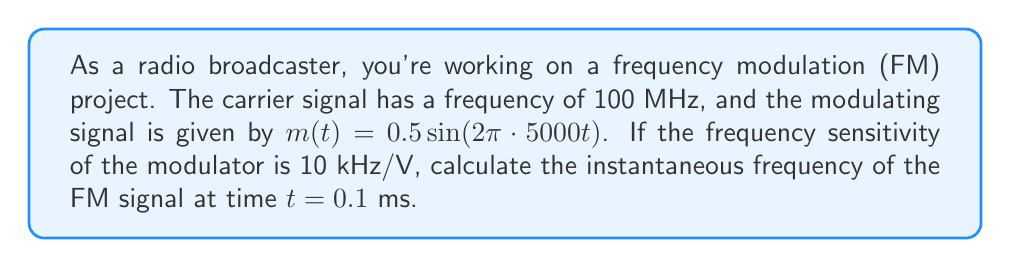Can you solve this math problem? To solve this problem, we'll follow these steps:

1) The general formula for the instantaneous frequency of an FM signal is:

   $$f_i(t) = f_c + k_f \cdot m(t)$$

   where $f_c$ is the carrier frequency, $k_f$ is the frequency sensitivity, and $m(t)$ is the modulating signal.

2) We're given:
   - $f_c = 100$ MHz $= 100 \cdot 10^6$ Hz
   - $k_f = 10$ kHz/V $= 10 \cdot 10^3$ Hz/V
   - $m(t) = 0.5 \sin(2\pi \cdot 5000t)$

3) Let's substitute these into our formula:

   $$f_i(t) = 100 \cdot 10^6 + 10 \cdot 10^3 \cdot 0.5 \sin(2\pi \cdot 5000t)$$

4) Simplify:

   $$f_i(t) = 100 \cdot 10^6 + 5 \cdot 10^3 \sin(10000\pi t)$$

5) Now, we need to calculate this at $t = 0.1$ ms $= 0.0001$ s:

   $$f_i(0.0001) = 100 \cdot 10^6 + 5 \cdot 10^3 \sin(10000\pi \cdot 0.0001)$$

6) Calculate the argument of sine:

   $$10000\pi \cdot 0.0001 = \pi$$

7) Therefore:

   $$f_i(0.0001) = 100 \cdot 10^6 + 5 \cdot 10^3 \sin(\pi) = 100 \cdot 10^6 + 5 \cdot 10^3 \cdot 0 = 100 \cdot 10^6$$

8) The instantaneous frequency at $t = 0.1$ ms is 100 MHz.
Answer: 100 MHz 